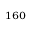<formula> <loc_0><loc_0><loc_500><loc_500>_ { 1 6 0 }</formula> 